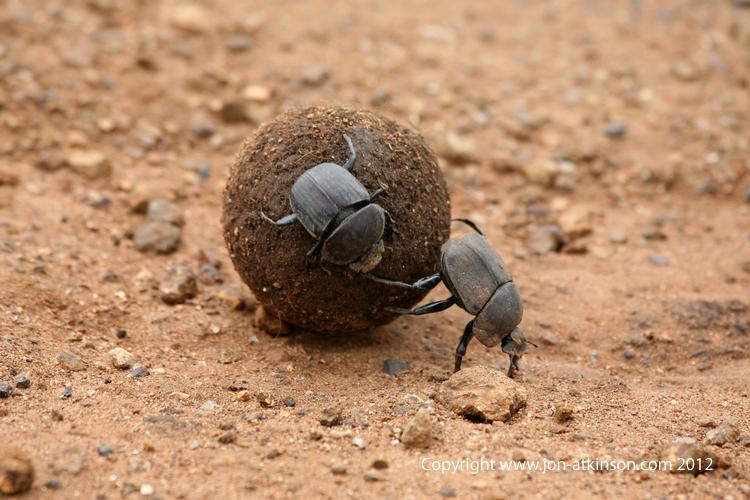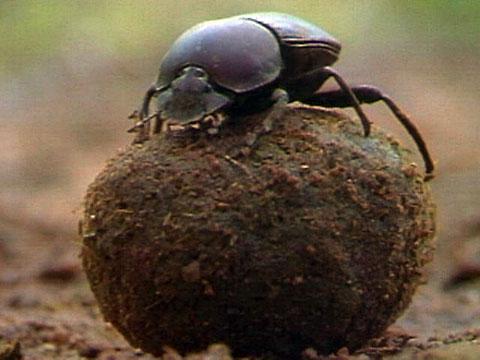The first image is the image on the left, the second image is the image on the right. Given the left and right images, does the statement "An image includes one dung ball and two beetles." hold true? Answer yes or no. Yes. The first image is the image on the left, the second image is the image on the right. Assess this claim about the two images: "There are 3 beetles present near a dung ball.". Correct or not? Answer yes or no. Yes. 